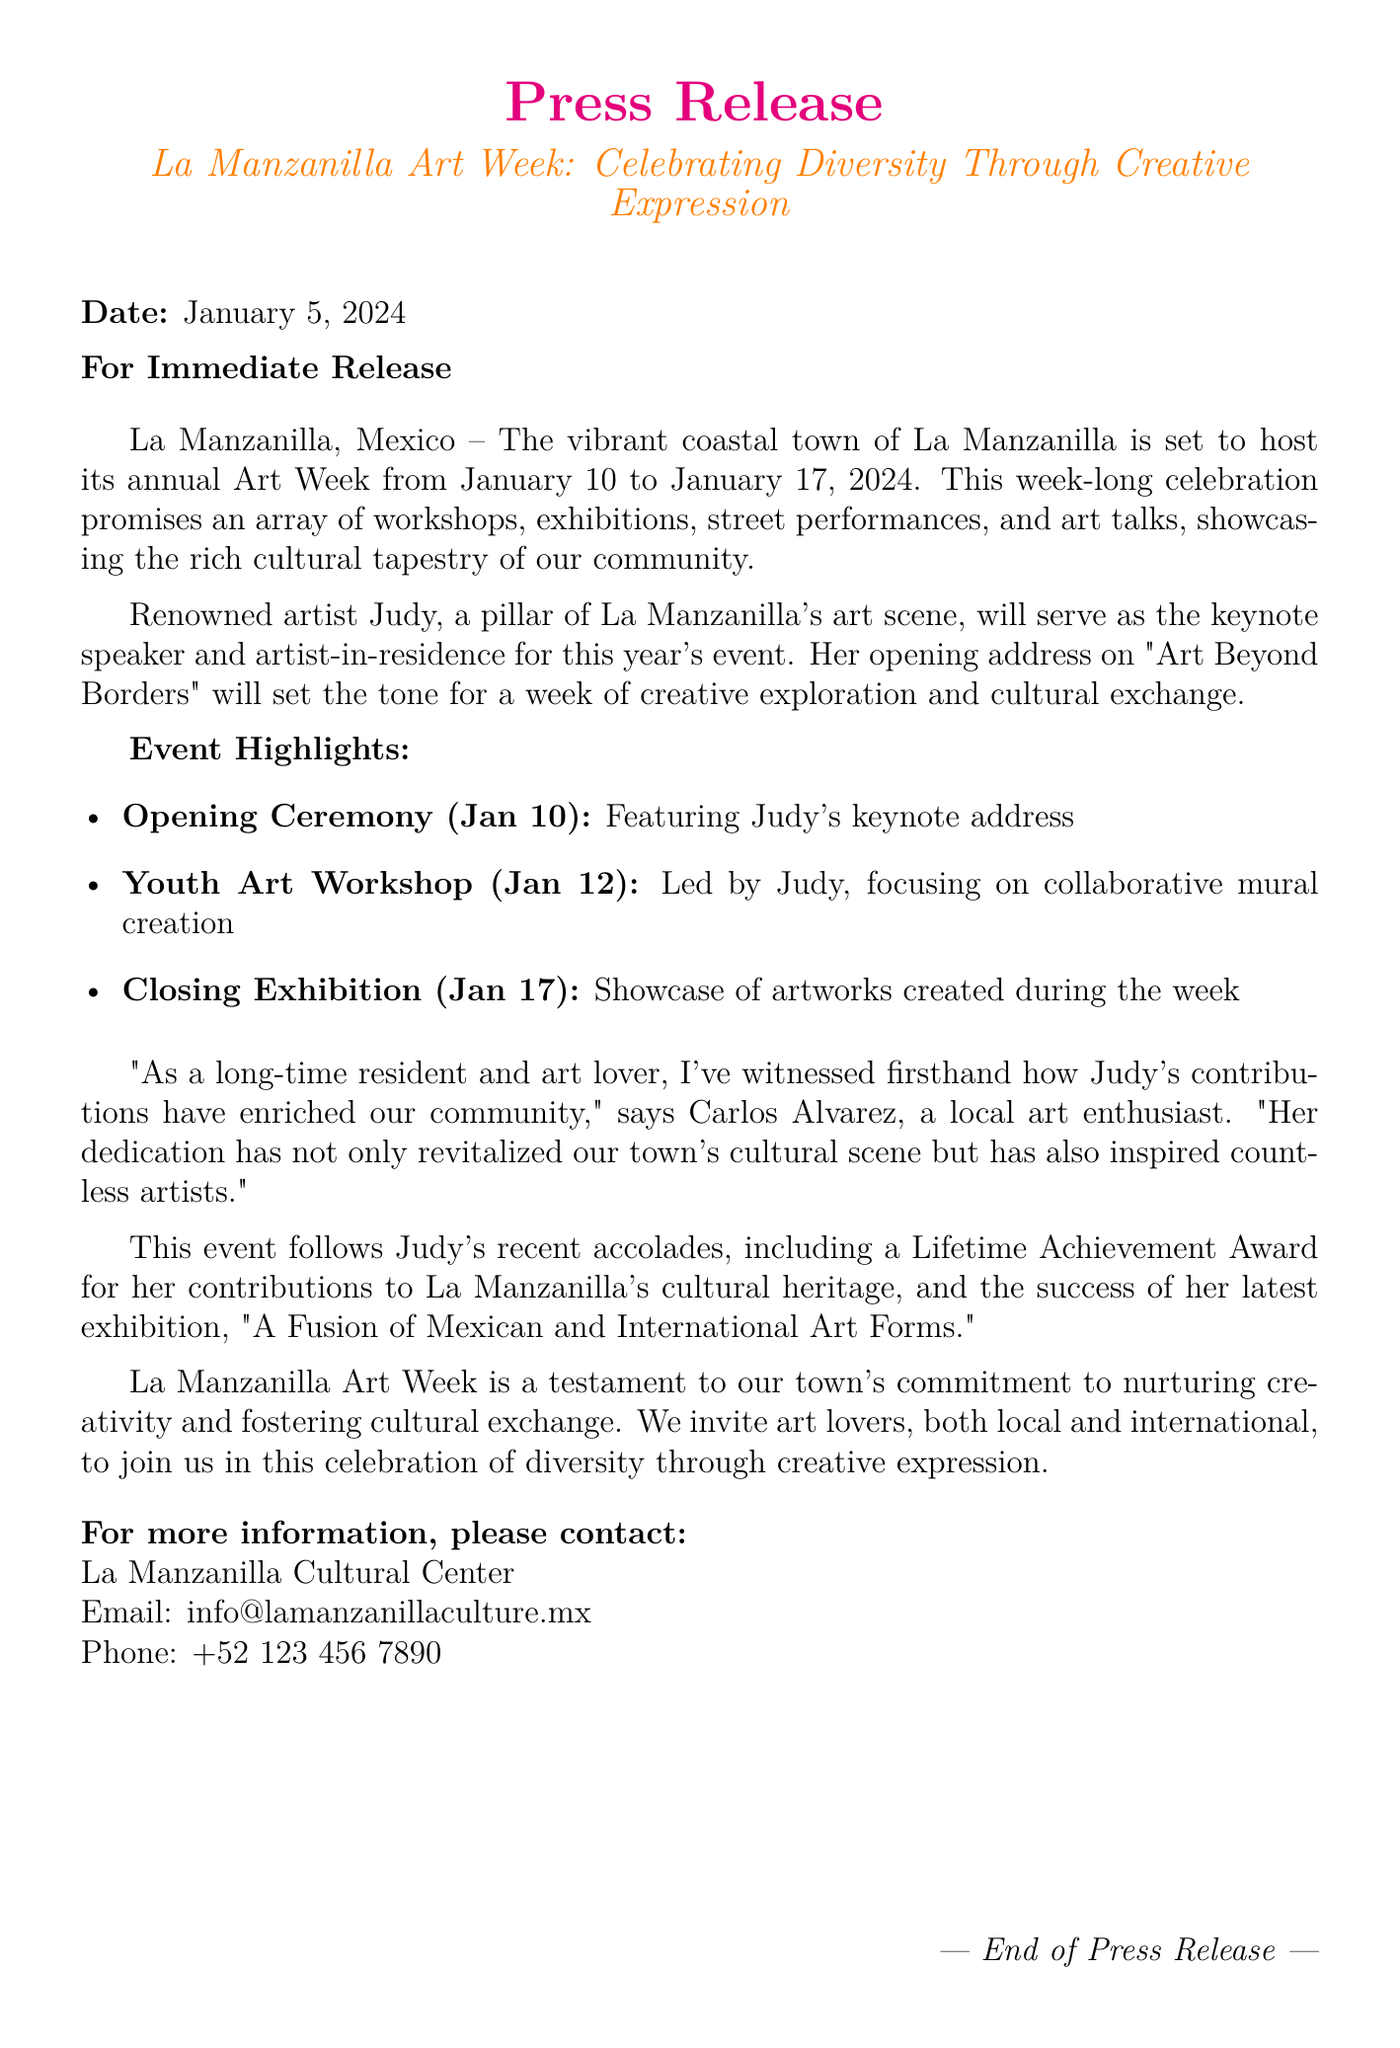What are the dates for La Manzanilla Art Week? The document states that La Manzanilla Art Week will occur from January 10 to January 17, 2024.
Answer: January 10 to January 17, 2024 Who is the keynote speaker for Art Week? The document mentions that Judy will serve as the keynote speaker for the event.
Answer: Judy What is the title of Judy's opening address? The opening address by Judy is titled "Art Beyond Borders," as mentioned in the document.
Answer: Art Beyond Borders What type of workshop will Judy lead during Art Week? The document specifies that Judy will lead a Youth Art Workshop focusing on collaborative mural creation.
Answer: Collaborative mural creation How many events are highlighted in the document? The document lists three key events: the opening ceremony, the youth art workshop, and the closing exhibition.
Answer: Three What award has Judy recently received? The document notes that Judy received a Lifetime Achievement Award for her contributions.
Answer: Lifetime Achievement Award What is the main theme of La Manzanilla Art Week? The document states that the theme is "Celebrating Diversity Through Creative Expression."
Answer: Celebrating Diversity Through Creative Expression What is the contact email for more information? The document provides the email info@lamanzanillaculture.mx for contact information.
Answer: info@lamanzanillaculture.mx 